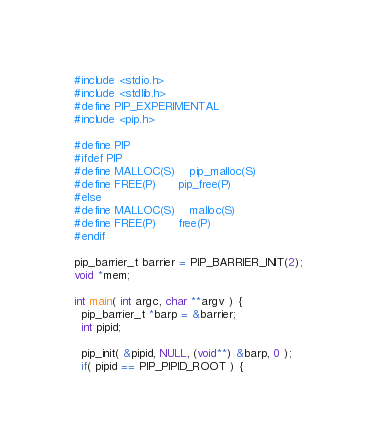<code> <loc_0><loc_0><loc_500><loc_500><_C_>#include <stdio.h>
#include <stdlib.h>
#define PIP_EXPERIMENTAL
#include <pip.h>

#define PIP
#ifdef PIP
#define MALLOC(S)	pip_malloc(S)
#define FREE(P)		pip_free(P)
#else
#define MALLOC(S)	malloc(S)
#define FREE(P)		free(P)
#endif

pip_barrier_t barrier = PIP_BARRIER_INIT(2);
void *mem;

int main( int argc, char **argv ) {
  pip_barrier_t *barp = &barrier;
  int pipid;

  pip_init( &pipid, NULL, (void**) &barp, 0 );
  if( pipid == PIP_PIPID_ROOT ) {</code> 